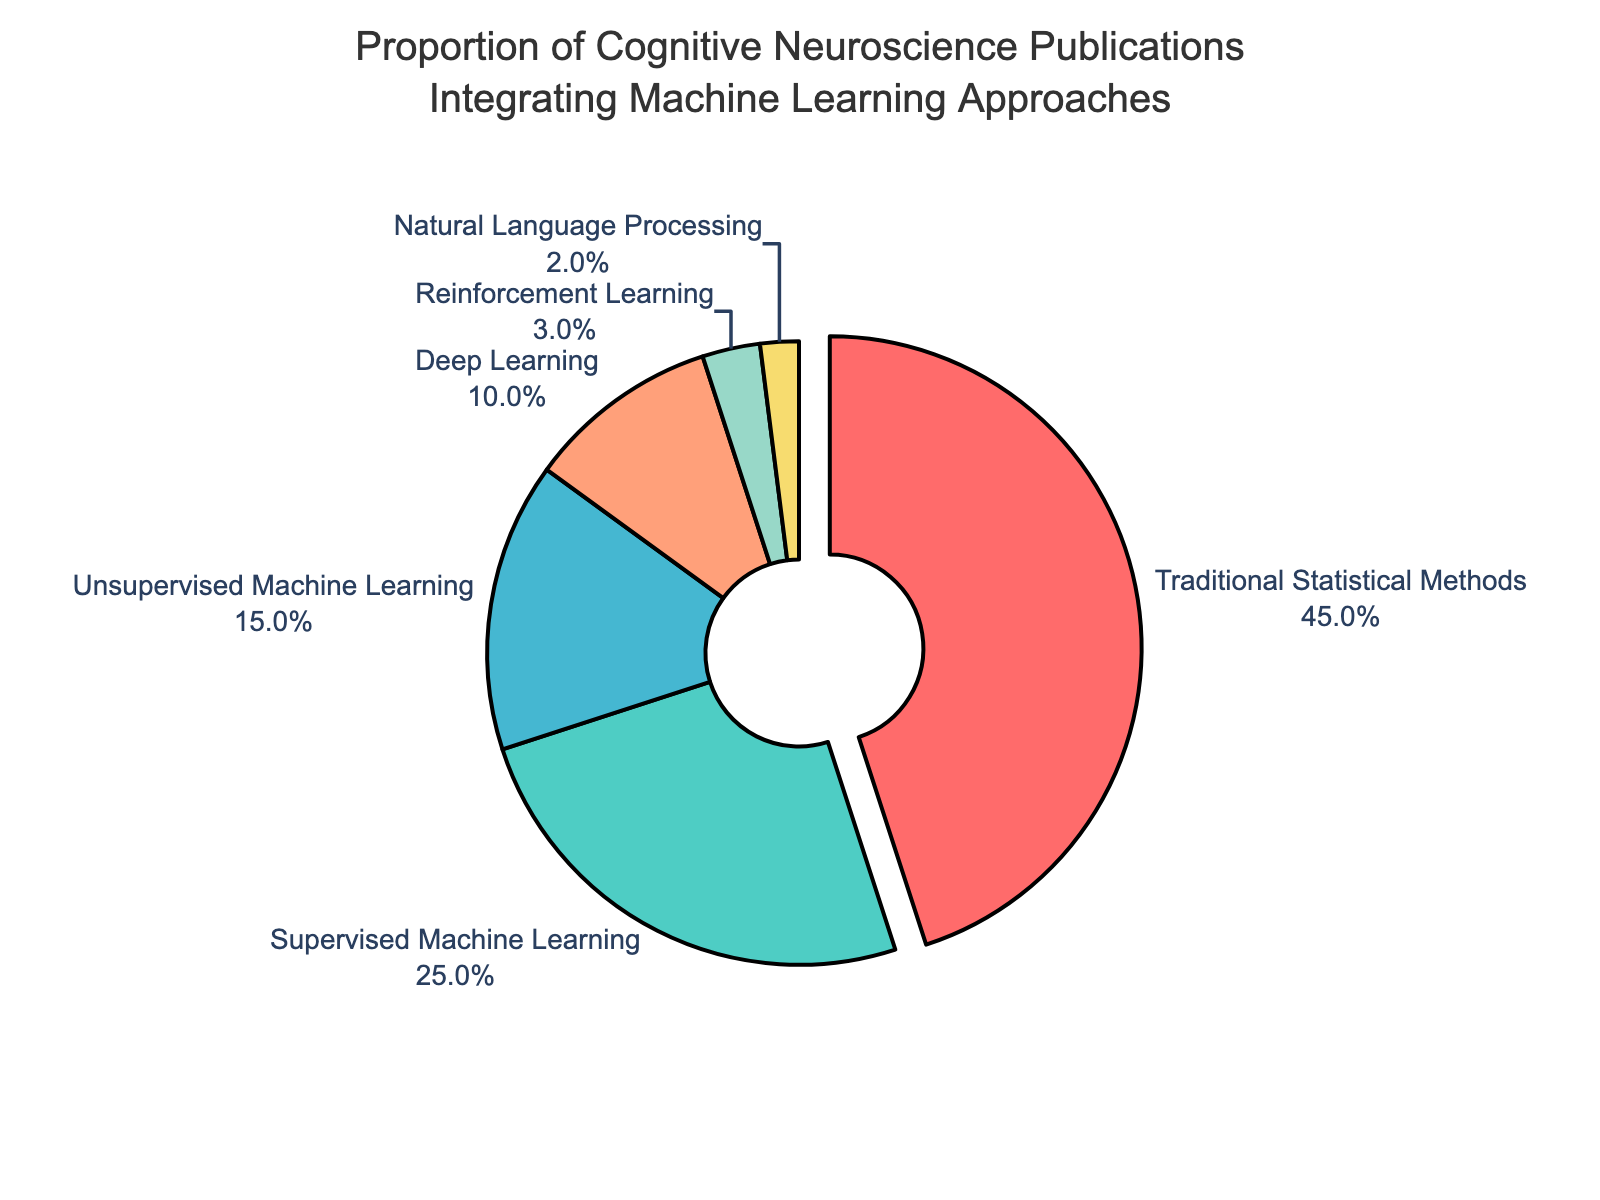What percentage of publications use Deep Learning? Locate the section of the pie chart labeled "Deep Learning" and refer to the percentage value shown.
Answer: 10% Which category has the least proportion of publications? Identify the smallest slice of the pie chart by visually comparing the size of each slice and refer to the label and percentage.
Answer: Natural Language Processing, 2% How much more prevalent is Supervised Machine Learning compared to Unsupervised Machine Learning? Find the slices labeled "Supervised Machine Learning" and "Unsupervised Machine Learning," note their percentages, and calculate the difference: 25% - 15% = 10%.
Answer: 10% Sum the percentages of publications that use Traditional Statistical Methods and all forms of Machine Learning. Add the percentages for "Traditional Statistical Methods," "Supervised Machine Learning," "Unsupervised Machine Learning," "Deep Learning," "Reinforcement Learning," and "Natural Language Processing": 45% + 25% + 15% + 10% + 3% + 2% = 100%.
Answer: 100% Which two categories combined cover half of the publications? Identify the two largest slices and add their percentages to see if they sum to about 50%: Traditional Statistical Methods (45%) + Supervised Machine Learning (25%) = 70%. This means we need to try a different combination. Instead, consider "Traditional Statistical Methods" and any smaller slice: Traditional Statistical Methods (45%) + Unsupervised Machine Learning (15%) = 60%, which is above 50%. Hence, the combination that gets closer: Traditional Statistical Methods (45%) + Deep Learning (10%) = 55%.
Answer: Traditional Statistical Methods and Supervised Machine Learning Comparing Reinforcement Learning and Natural Language Processing, which has a greater proportion, and by how much? Find the slices labeled "Reinforcement Learning" and "Natural Language Processing": Reinforcement Learning (3%) and Natural Language Processing (2%). Calculate the difference: 3% - 2% = 1%.
Answer: Reinforcement Learning, 1% What is the ratio of publications that use Traditional Statistical Methods to those that use Unsupervised Machine Learning? Locate the slices for "Traditional Statistical Methods" and "Unsupervised Machine Learning" and convert their percentages into a ratio: 45% (Traditional Statistical Methods) / 15% (Unsupervised Machine Learning) = 3:1.
Answer: 3:1 What proportion of publications fall under Supervised Machine Learning, Unsupervised Machine Learning, and Deep Learning combined? Add the percentages for "Supervised Machine Learning," "Unsupervised Machine Learning," and "Deep Learning": 25% + 15% + 10% = 50%.
Answer: 50% Which category is represented using the largest slice of the pie chart? Observe the pie chart and look for the largest slice by area, noting its label and percentage.
Answer: Traditional Statistical Methods, 45% How much less common is Reinforcement Learning compared to Traditional Statistical Methods? Note the percentages for "Reinforcement Learning" and "Traditional Statistical Methods," then subtract: 45% - 3% = 42%.
Answer: 42% 